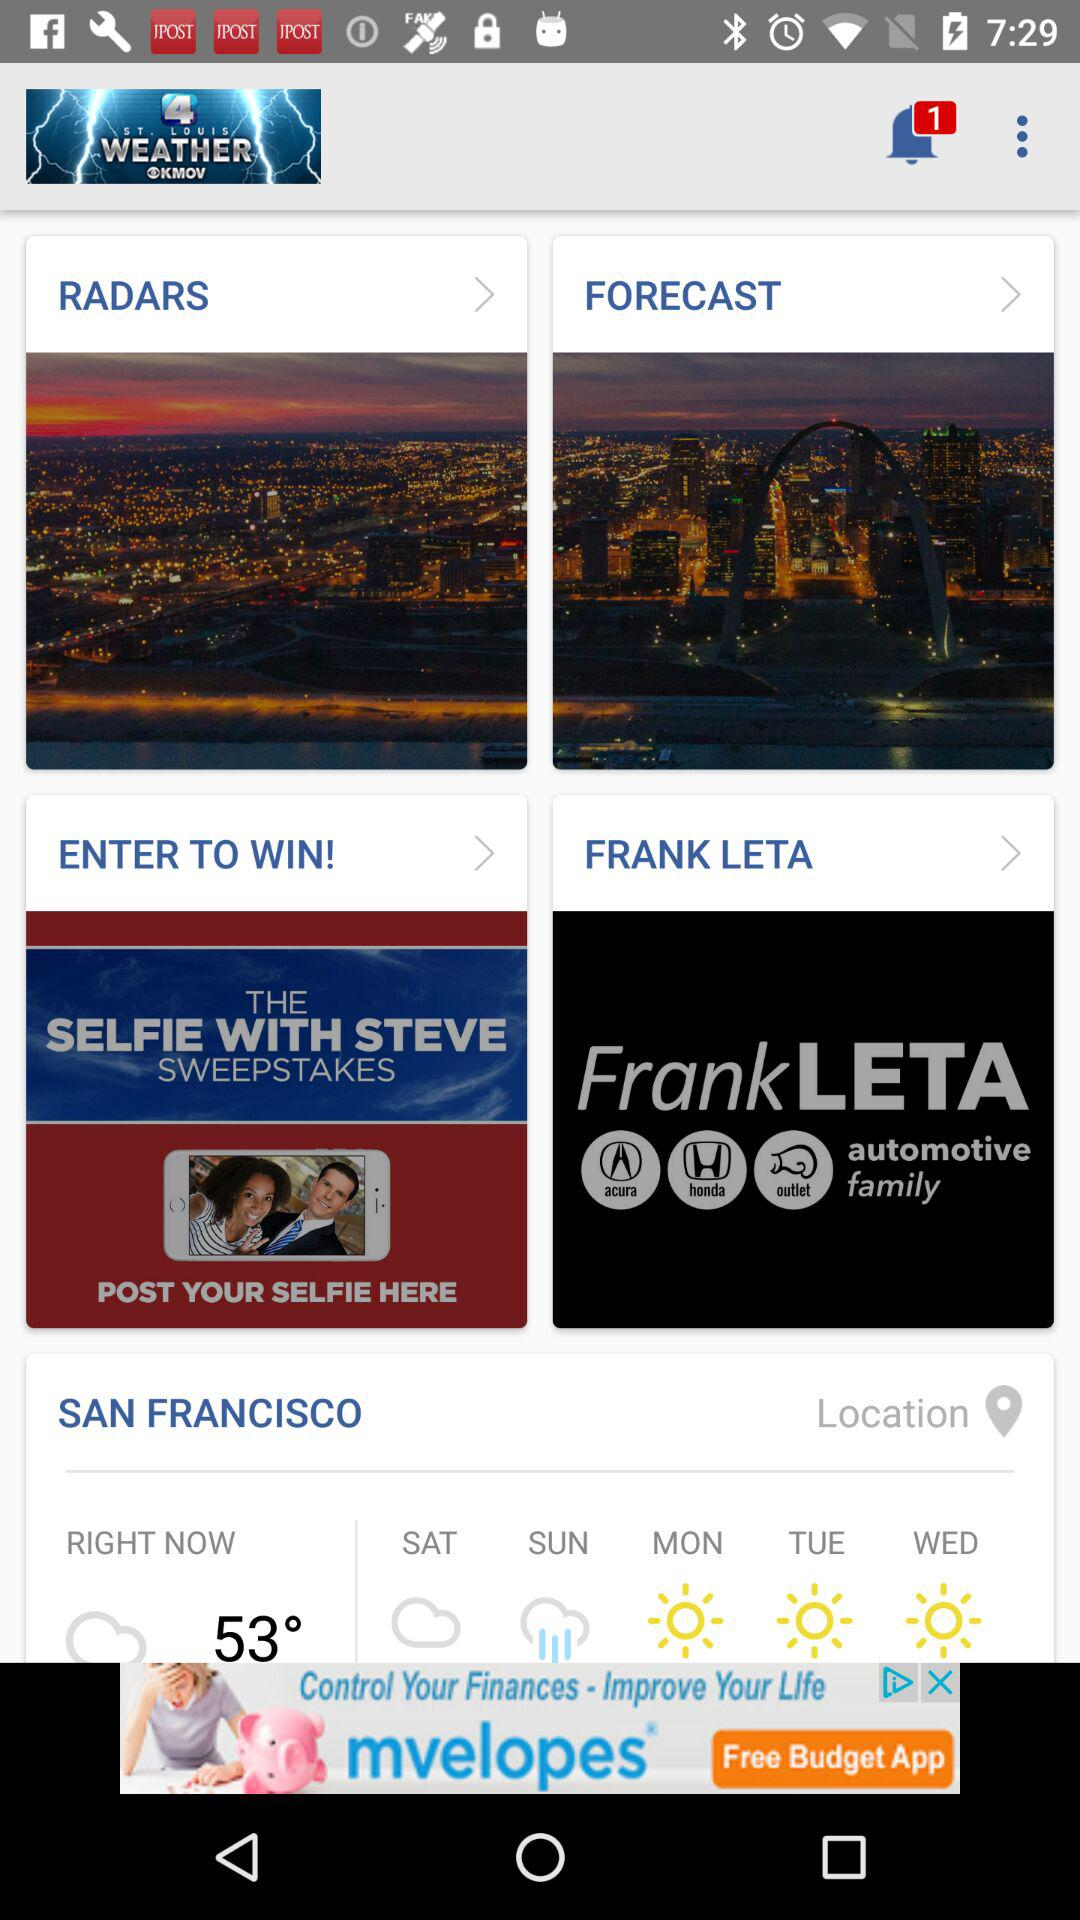What is the current wheather?
When the provided information is insufficient, respond with <no answer>. <no answer> 